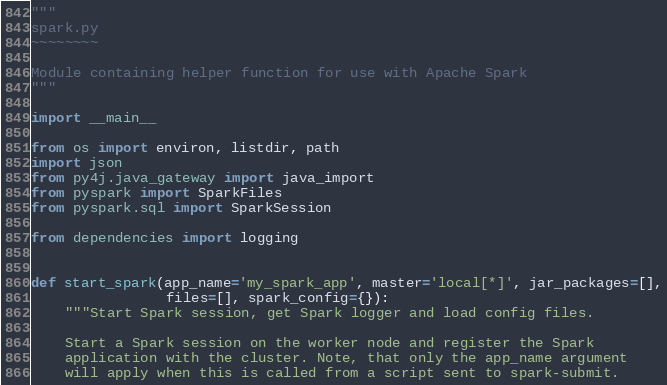Convert code to text. <code><loc_0><loc_0><loc_500><loc_500><_Python_>"""
spark.py
~~~~~~~~

Module containing helper function for use with Apache Spark
"""

import __main__

from os import environ, listdir, path
import json
from py4j.java_gateway import java_import
from pyspark import SparkFiles
from pyspark.sql import SparkSession

from dependencies import logging


def start_spark(app_name='my_spark_app', master='local[*]', jar_packages=[],
                files=[], spark_config={}):
    """Start Spark session, get Spark logger and load config files.

    Start a Spark session on the worker node and register the Spark
    application with the cluster. Note, that only the app_name argument
    will apply when this is called from a script sent to spark-submit.</code> 